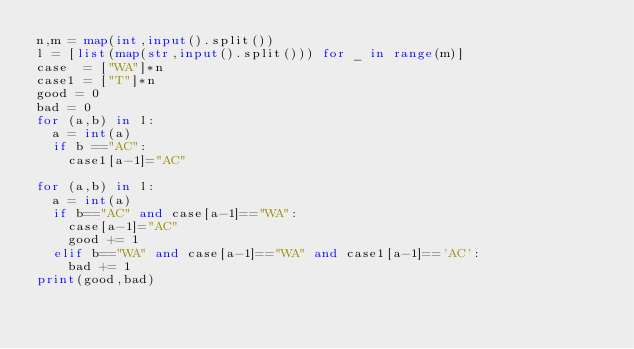<code> <loc_0><loc_0><loc_500><loc_500><_Python_>n,m = map(int,input().split())
l = [list(map(str,input().split())) for _ in range(m)]
case  = ["WA"]*n
case1 = ["T"]*n
good = 0
bad = 0
for (a,b) in l:
  a = int(a)
  if b =="AC":
    case1[a-1]="AC"
    
for (a,b) in l:
  a = int(a)
  if b=="AC" and case[a-1]=="WA":
    case[a-1]="AC"
    good += 1
  elif b=="WA" and case[a-1]=="WA" and case1[a-1]=='AC':
    bad += 1
print(good,bad)
    
  </code> 